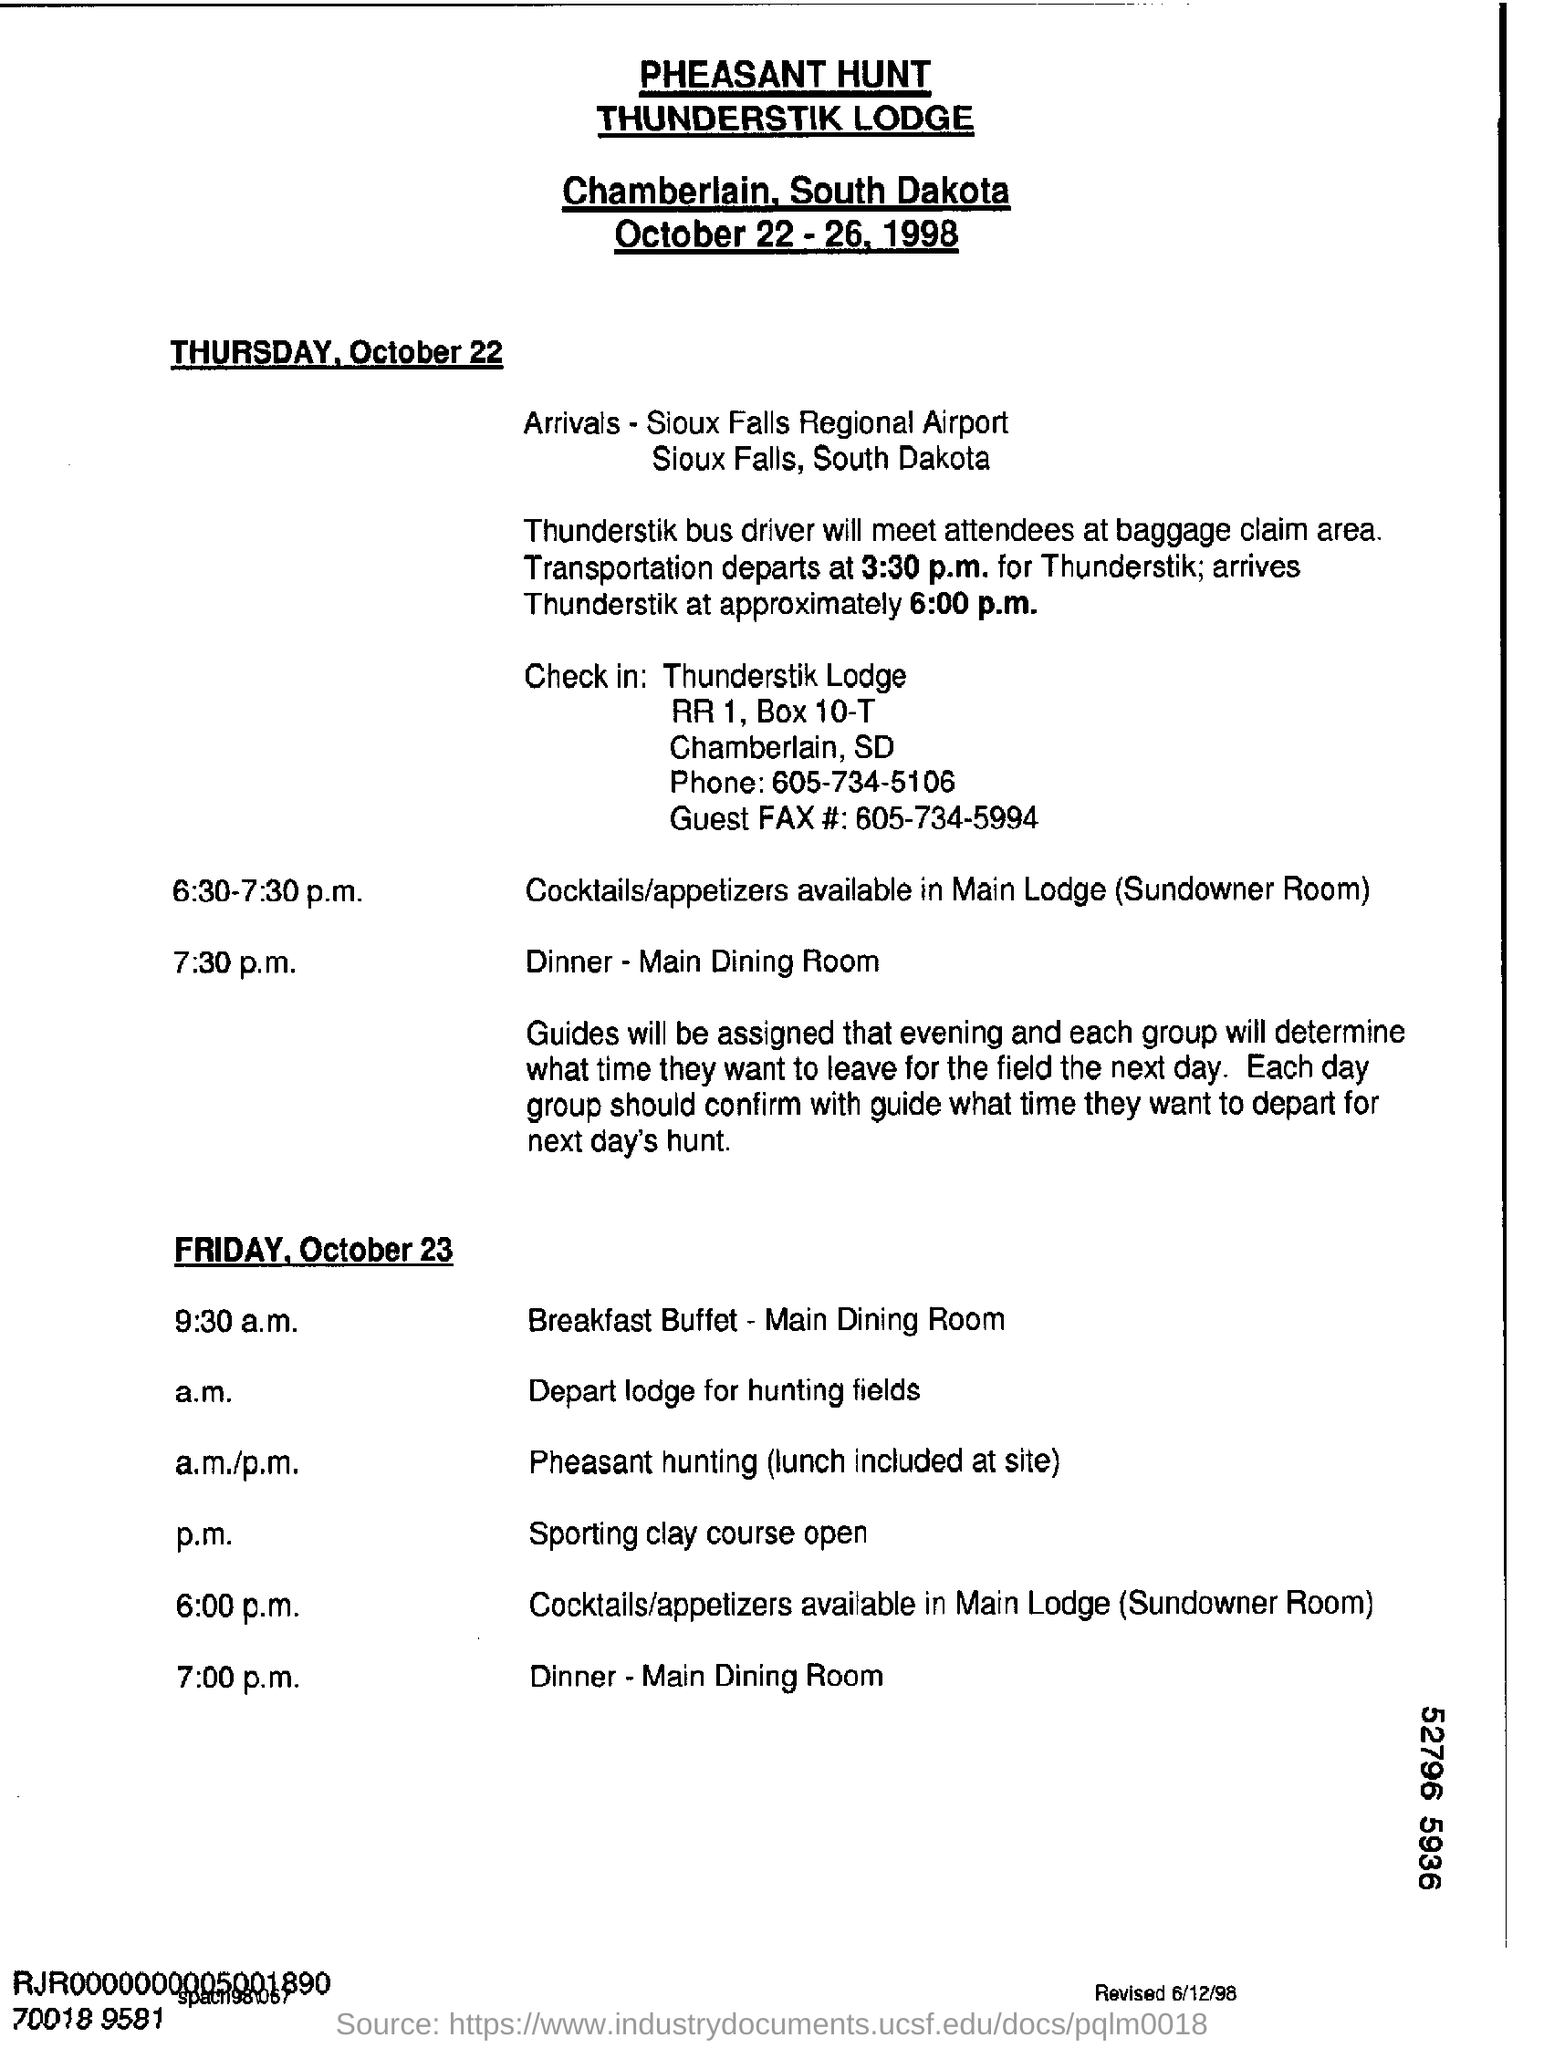What is the name of the Lodge?
Your response must be concise. Thunderstik lodge. Where is it located?
Your answer should be compact. Chamberlain, South Dakota. Where will the Thunderstik bus driver meet attendees?
Your answer should be very brief. At baggage claim area. When does transportation depart?
Your answer should be very brief. 3:30 p.m. When does it arrive at Thunderstik?
Make the answer very short. Approximately 6:00 p.m. Where is the dinner held?
Provide a short and direct response. Main dining room. 